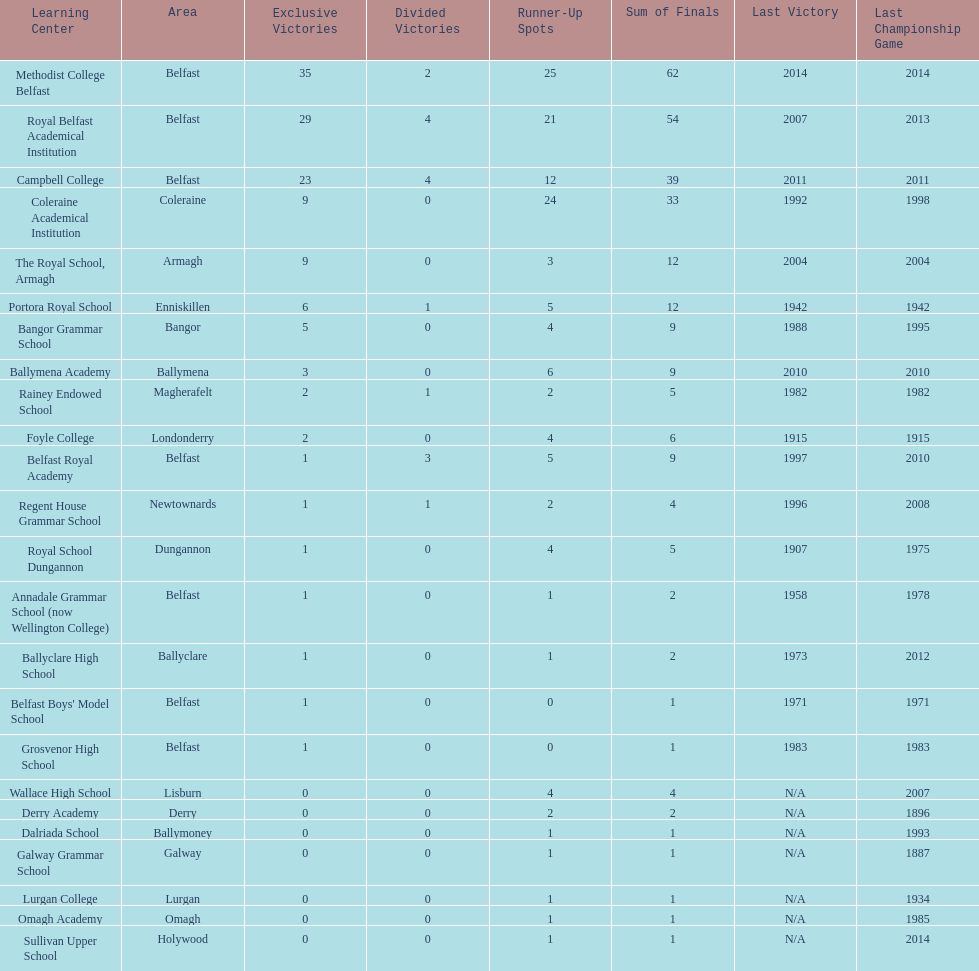How many schools have had at least 3 share titles? 3. 